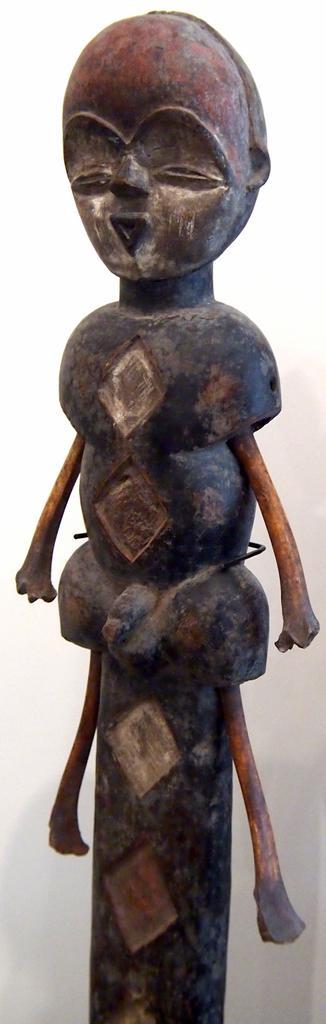In one or two sentences, can you explain what this image depicts? In this image we can see a statue. In the background it is white. 